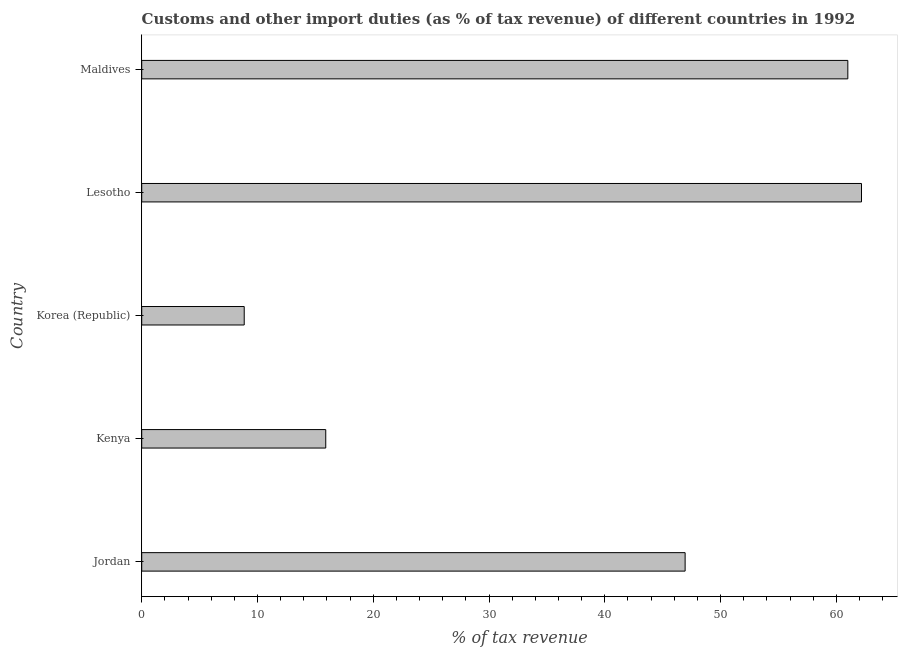Does the graph contain grids?
Ensure brevity in your answer.  No. What is the title of the graph?
Offer a terse response. Customs and other import duties (as % of tax revenue) of different countries in 1992. What is the label or title of the X-axis?
Your answer should be very brief. % of tax revenue. What is the label or title of the Y-axis?
Offer a very short reply. Country. What is the customs and other import duties in Lesotho?
Provide a succinct answer. 62.17. Across all countries, what is the maximum customs and other import duties?
Your response must be concise. 62.17. Across all countries, what is the minimum customs and other import duties?
Your response must be concise. 8.85. In which country was the customs and other import duties maximum?
Provide a short and direct response. Lesotho. In which country was the customs and other import duties minimum?
Keep it short and to the point. Korea (Republic). What is the sum of the customs and other import duties?
Your response must be concise. 194.85. What is the difference between the customs and other import duties in Jordan and Kenya?
Make the answer very short. 31.04. What is the average customs and other import duties per country?
Make the answer very short. 38.97. What is the median customs and other import duties?
Give a very brief answer. 46.94. In how many countries, is the customs and other import duties greater than 58 %?
Ensure brevity in your answer.  2. What is the ratio of the customs and other import duties in Korea (Republic) to that in Maldives?
Provide a succinct answer. 0.14. Is the customs and other import duties in Kenya less than that in Maldives?
Your response must be concise. Yes. Is the difference between the customs and other import duties in Jordan and Maldives greater than the difference between any two countries?
Provide a succinct answer. No. What is the difference between the highest and the second highest customs and other import duties?
Your answer should be compact. 1.18. Is the sum of the customs and other import duties in Jordan and Maldives greater than the maximum customs and other import duties across all countries?
Make the answer very short. Yes. What is the difference between the highest and the lowest customs and other import duties?
Make the answer very short. 53.32. What is the difference between two consecutive major ticks on the X-axis?
Offer a terse response. 10. Are the values on the major ticks of X-axis written in scientific E-notation?
Provide a short and direct response. No. What is the % of tax revenue in Jordan?
Keep it short and to the point. 46.94. What is the % of tax revenue of Kenya?
Give a very brief answer. 15.89. What is the % of tax revenue in Korea (Republic)?
Provide a succinct answer. 8.85. What is the % of tax revenue of Lesotho?
Make the answer very short. 62.17. What is the % of tax revenue in Maldives?
Keep it short and to the point. 60.99. What is the difference between the % of tax revenue in Jordan and Kenya?
Make the answer very short. 31.04. What is the difference between the % of tax revenue in Jordan and Korea (Republic)?
Offer a terse response. 38.08. What is the difference between the % of tax revenue in Jordan and Lesotho?
Your answer should be compact. -15.23. What is the difference between the % of tax revenue in Jordan and Maldives?
Make the answer very short. -14.05. What is the difference between the % of tax revenue in Kenya and Korea (Republic)?
Offer a very short reply. 7.04. What is the difference between the % of tax revenue in Kenya and Lesotho?
Ensure brevity in your answer.  -46.28. What is the difference between the % of tax revenue in Kenya and Maldives?
Offer a very short reply. -45.1. What is the difference between the % of tax revenue in Korea (Republic) and Lesotho?
Keep it short and to the point. -53.32. What is the difference between the % of tax revenue in Korea (Republic) and Maldives?
Make the answer very short. -52.14. What is the difference between the % of tax revenue in Lesotho and Maldives?
Ensure brevity in your answer.  1.18. What is the ratio of the % of tax revenue in Jordan to that in Kenya?
Your response must be concise. 2.95. What is the ratio of the % of tax revenue in Jordan to that in Korea (Republic)?
Provide a succinct answer. 5.3. What is the ratio of the % of tax revenue in Jordan to that in Lesotho?
Ensure brevity in your answer.  0.76. What is the ratio of the % of tax revenue in Jordan to that in Maldives?
Your response must be concise. 0.77. What is the ratio of the % of tax revenue in Kenya to that in Korea (Republic)?
Ensure brevity in your answer.  1.79. What is the ratio of the % of tax revenue in Kenya to that in Lesotho?
Your response must be concise. 0.26. What is the ratio of the % of tax revenue in Kenya to that in Maldives?
Your answer should be very brief. 0.26. What is the ratio of the % of tax revenue in Korea (Republic) to that in Lesotho?
Ensure brevity in your answer.  0.14. What is the ratio of the % of tax revenue in Korea (Republic) to that in Maldives?
Make the answer very short. 0.14. What is the ratio of the % of tax revenue in Lesotho to that in Maldives?
Provide a short and direct response. 1.02. 